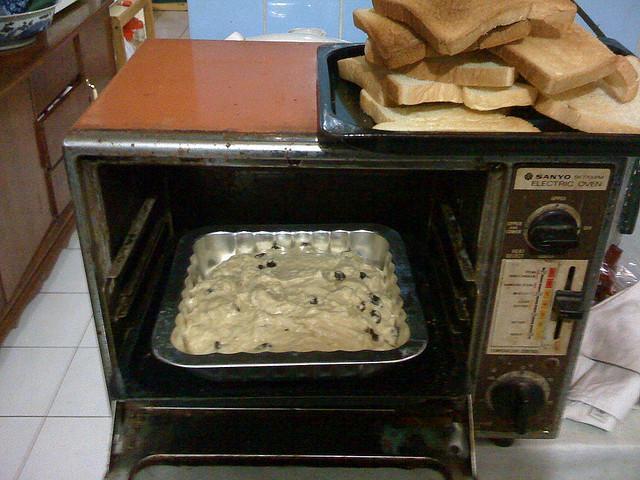How many Smokies are been cooked?
Give a very brief answer. 0. 